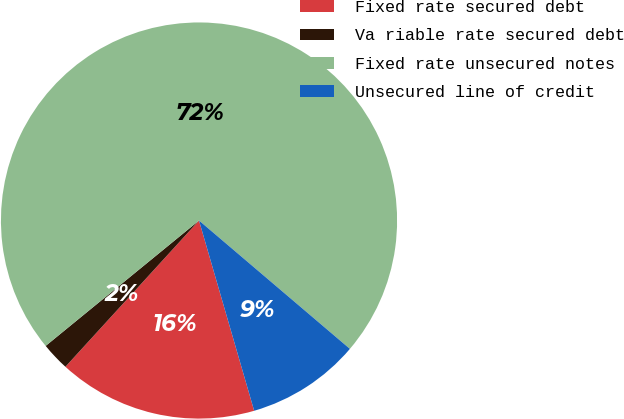Convert chart to OTSL. <chart><loc_0><loc_0><loc_500><loc_500><pie_chart><fcel>Fixed rate secured debt<fcel>Va riable rate secured debt<fcel>Fixed rate unsecured notes<fcel>Unsecured line of credit<nl><fcel>16.27%<fcel>2.31%<fcel>72.12%<fcel>9.29%<nl></chart> 